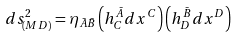Convert formula to latex. <formula><loc_0><loc_0><loc_500><loc_500>d s ^ { 2 } _ { ( M D ) } = \eta _ { \bar { A } \bar { B } } \left ( h ^ { \bar { A } } _ { C } d x ^ { C } \right ) \left ( h ^ { \bar { B } } _ { D } d x ^ { D } \right )</formula> 